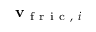Convert formula to latex. <formula><loc_0><loc_0><loc_500><loc_500>v _ { f r i c , i }</formula> 